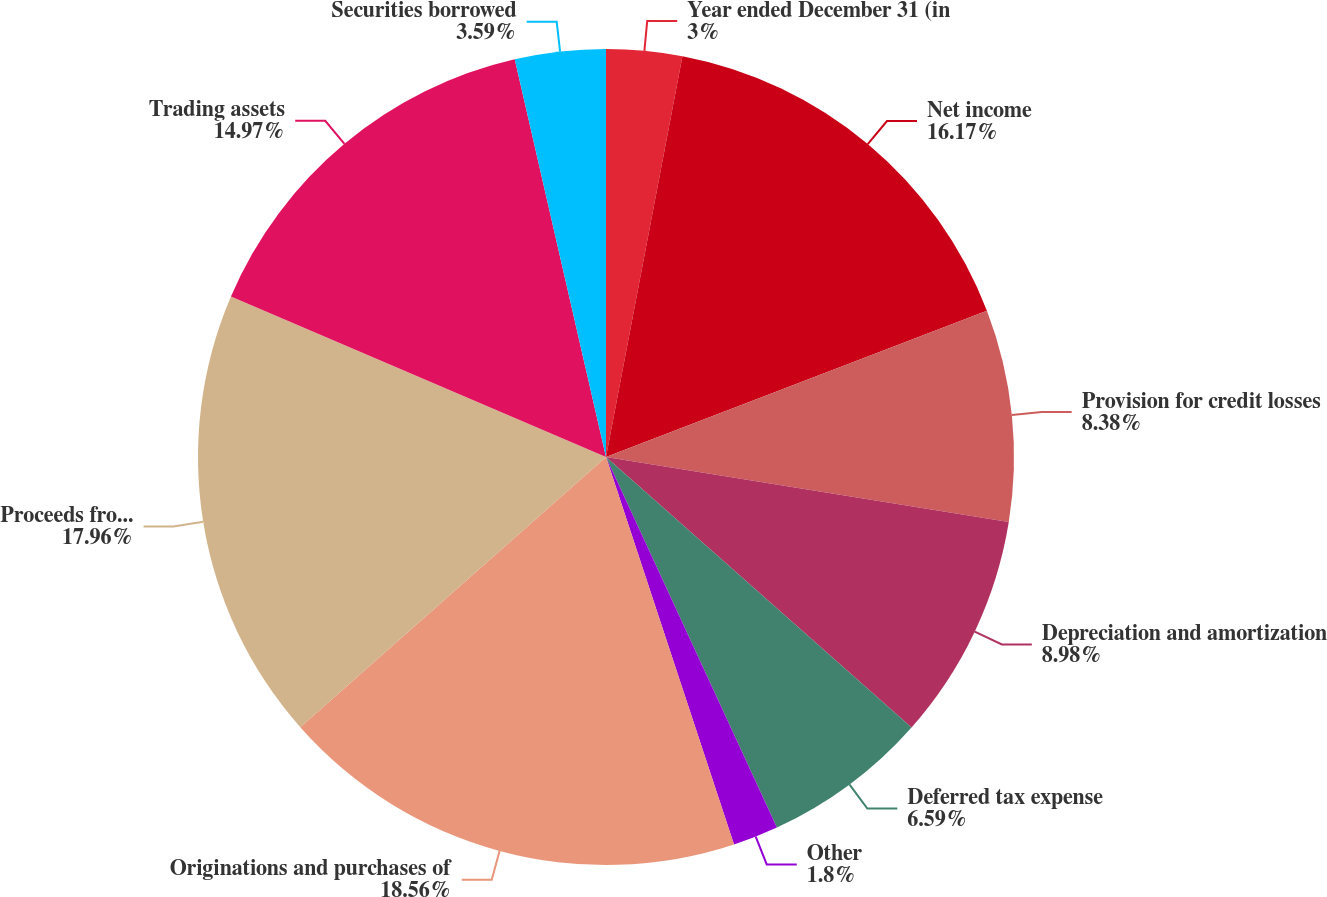<chart> <loc_0><loc_0><loc_500><loc_500><pie_chart><fcel>Year ended December 31 (in<fcel>Net income<fcel>Provision for credit losses<fcel>Depreciation and amortization<fcel>Deferred tax expense<fcel>Other<fcel>Originations and purchases of<fcel>Proceeds from sales<fcel>Trading assets<fcel>Securities borrowed<nl><fcel>3.0%<fcel>16.17%<fcel>8.38%<fcel>8.98%<fcel>6.59%<fcel>1.8%<fcel>18.56%<fcel>17.96%<fcel>14.97%<fcel>3.59%<nl></chart> 